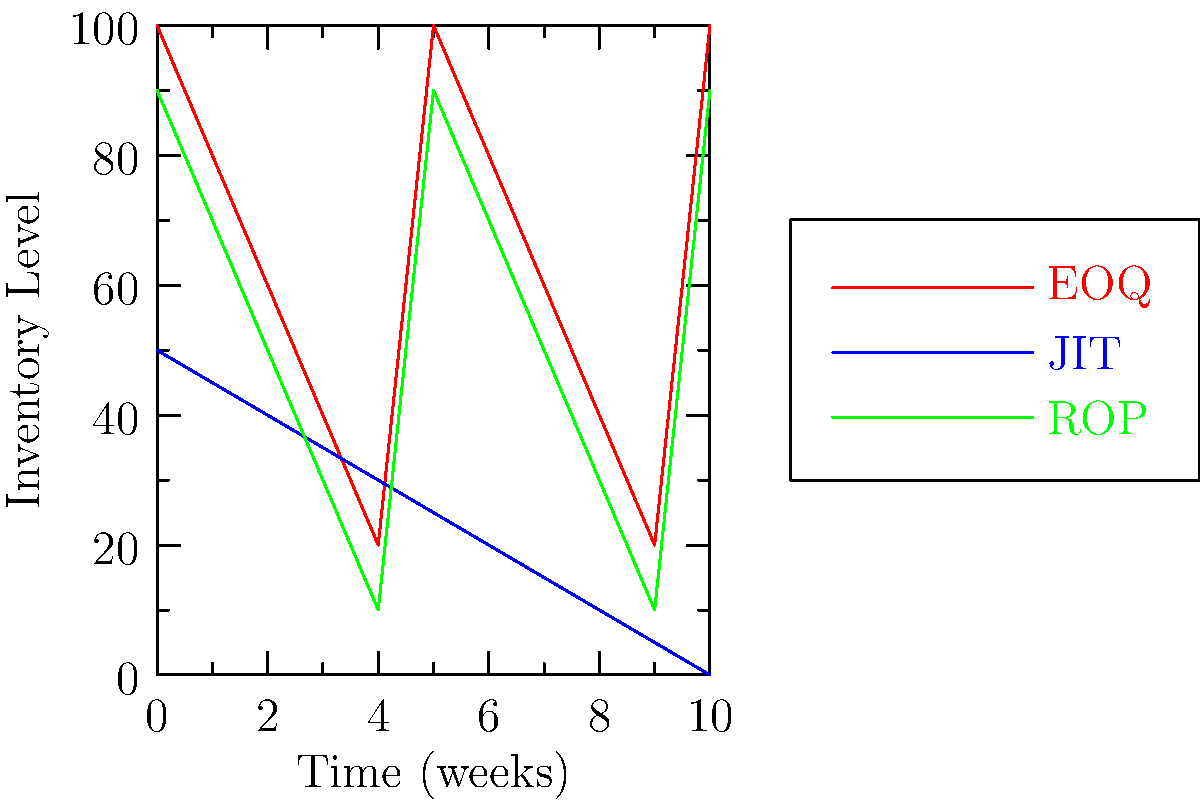The graph shows inventory levels over time for three different inventory management models: Economic Order Quantity (EOQ), Just-in-Time (JIT), and Reorder Point (ROP). Based on the graph, which model demonstrates the most consistent inventory level, and what does this imply about its operational efficiency? To answer this question, we need to analyze the patterns of each inventory management model:

1. EOQ (red line):
   - Shows a sawtooth pattern
   - Inventory levels fluctuate between 100 and 20 units
   - Cycle repeats every 5 weeks

2. JIT (blue line):
   - Shows a gradual, steady decline
   - Inventory levels decrease from 50 to 0 units over 10 weeks
   - No sudden jumps or fluctuations

3. ROP (green line):
   - Similar to EOQ, but with smaller fluctuations
   - Inventory levels fluctuate between 90 and 10 units
   - Cycle repeats every 5 weeks

The JIT model demonstrates the most consistent inventory level because:
- It has a smooth, gradual decline without sudden jumps or fluctuations
- The rate of inventory decrease is constant over time

This consistency implies higher operational efficiency for JIT because:
1. It minimizes holding costs by maintaining lower average inventory levels
2. It reduces the risk of stockouts or excess inventory
3. It allows for better cash flow management due to smaller, more frequent orders
4. It promotes a lean manufacturing approach, reducing waste and improving process flow

However, it's important to note that JIT requires precise coordination with suppliers and may be more vulnerable to supply chain disruptions. The choice of inventory model depends on various factors such as demand patterns, lead times, and supply chain reliability.
Answer: Just-in-Time (JIT), implying higher operational efficiency through consistent inventory reduction and lower holding costs. 